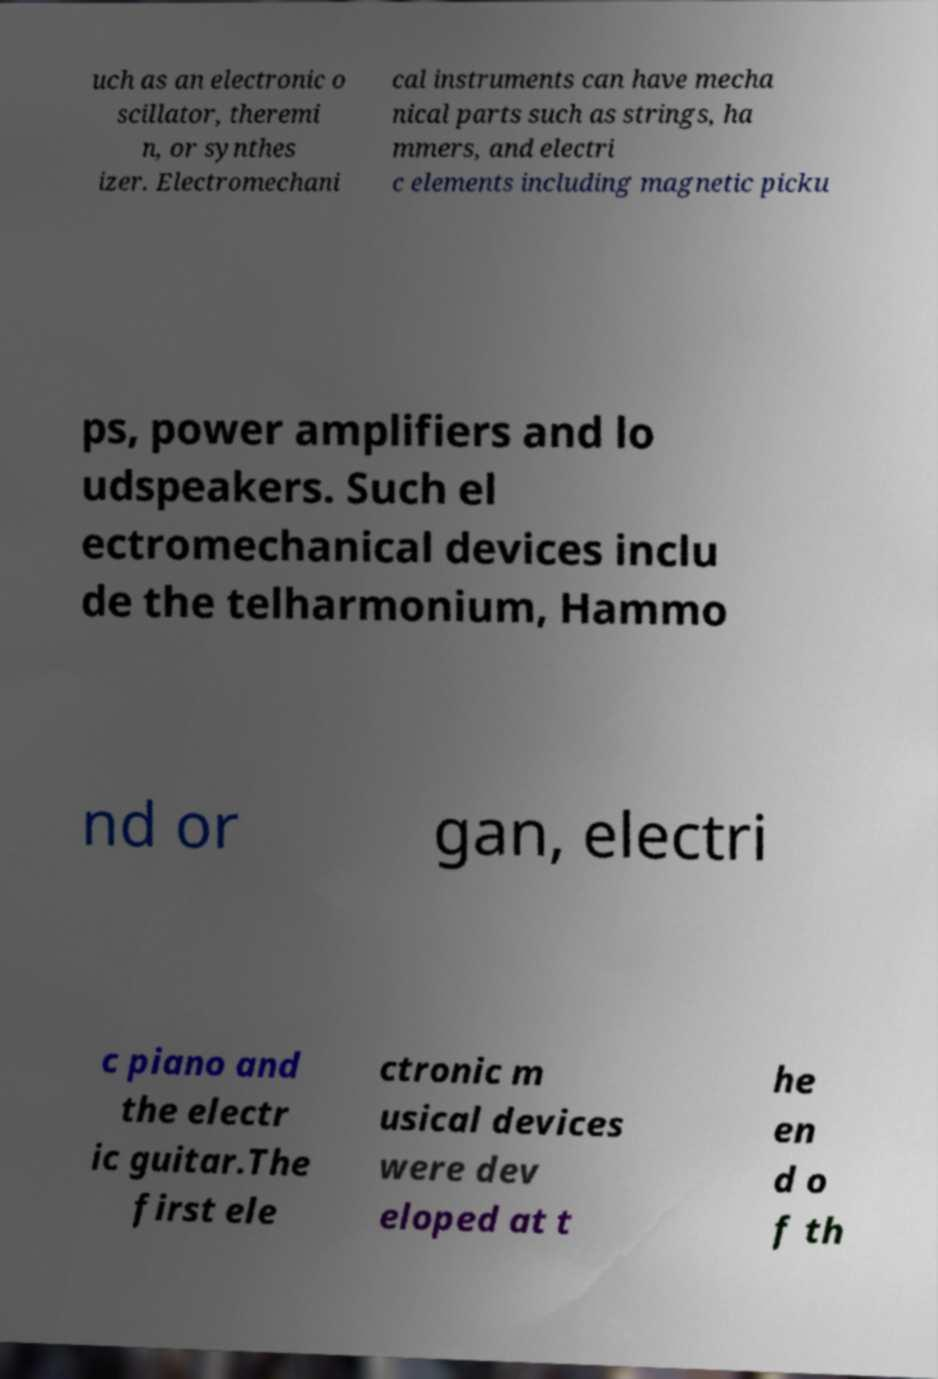Can you read and provide the text displayed in the image?This photo seems to have some interesting text. Can you extract and type it out for me? uch as an electronic o scillator, theremi n, or synthes izer. Electromechani cal instruments can have mecha nical parts such as strings, ha mmers, and electri c elements including magnetic picku ps, power amplifiers and lo udspeakers. Such el ectromechanical devices inclu de the telharmonium, Hammo nd or gan, electri c piano and the electr ic guitar.The first ele ctronic m usical devices were dev eloped at t he en d o f th 